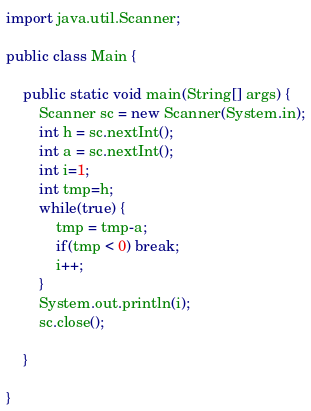Convert code to text. <code><loc_0><loc_0><loc_500><loc_500><_Java_>import java.util.Scanner;

public class Main {

	public static void main(String[] args) {
		Scanner sc = new Scanner(System.in);
		int h = sc.nextInt();
		int a = sc.nextInt();
		int i=1;
		int tmp=h;
		while(true) {
			tmp = tmp-a;
			if(tmp < 0) break;
			i++;
		}
		System.out.println(i);
		sc.close();

	}

}</code> 